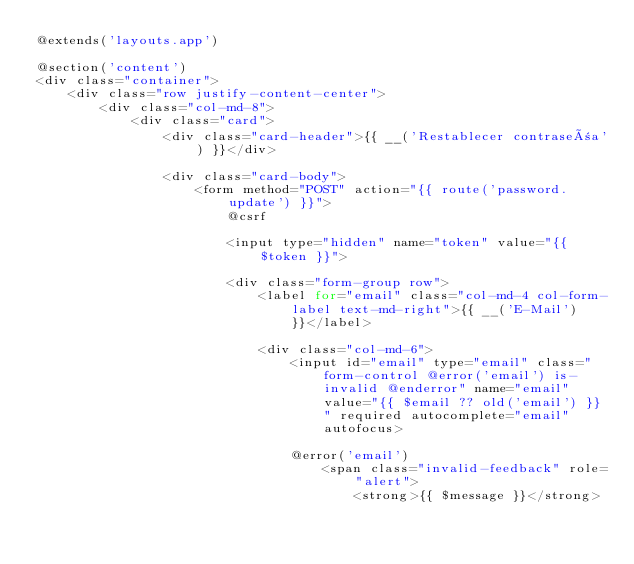Convert code to text. <code><loc_0><loc_0><loc_500><loc_500><_PHP_>@extends('layouts.app')

@section('content')
<div class="container">
    <div class="row justify-content-center">
        <div class="col-md-8">
            <div class="card">
                <div class="card-header">{{ __('Restablecer contraseña') }}</div>

                <div class="card-body">
                    <form method="POST" action="{{ route('password.update') }}">
                        @csrf

                        <input type="hidden" name="token" value="{{ $token }}">

                        <div class="form-group row">
                            <label for="email" class="col-md-4 col-form-label text-md-right">{{ __('E-Mail') }}</label>

                            <div class="col-md-6">
                                <input id="email" type="email" class="form-control @error('email') is-invalid @enderror" name="email" value="{{ $email ?? old('email') }}" required autocomplete="email" autofocus>

                                @error('email')
                                    <span class="invalid-feedback" role="alert">
                                        <strong>{{ $message }}</strong></code> 